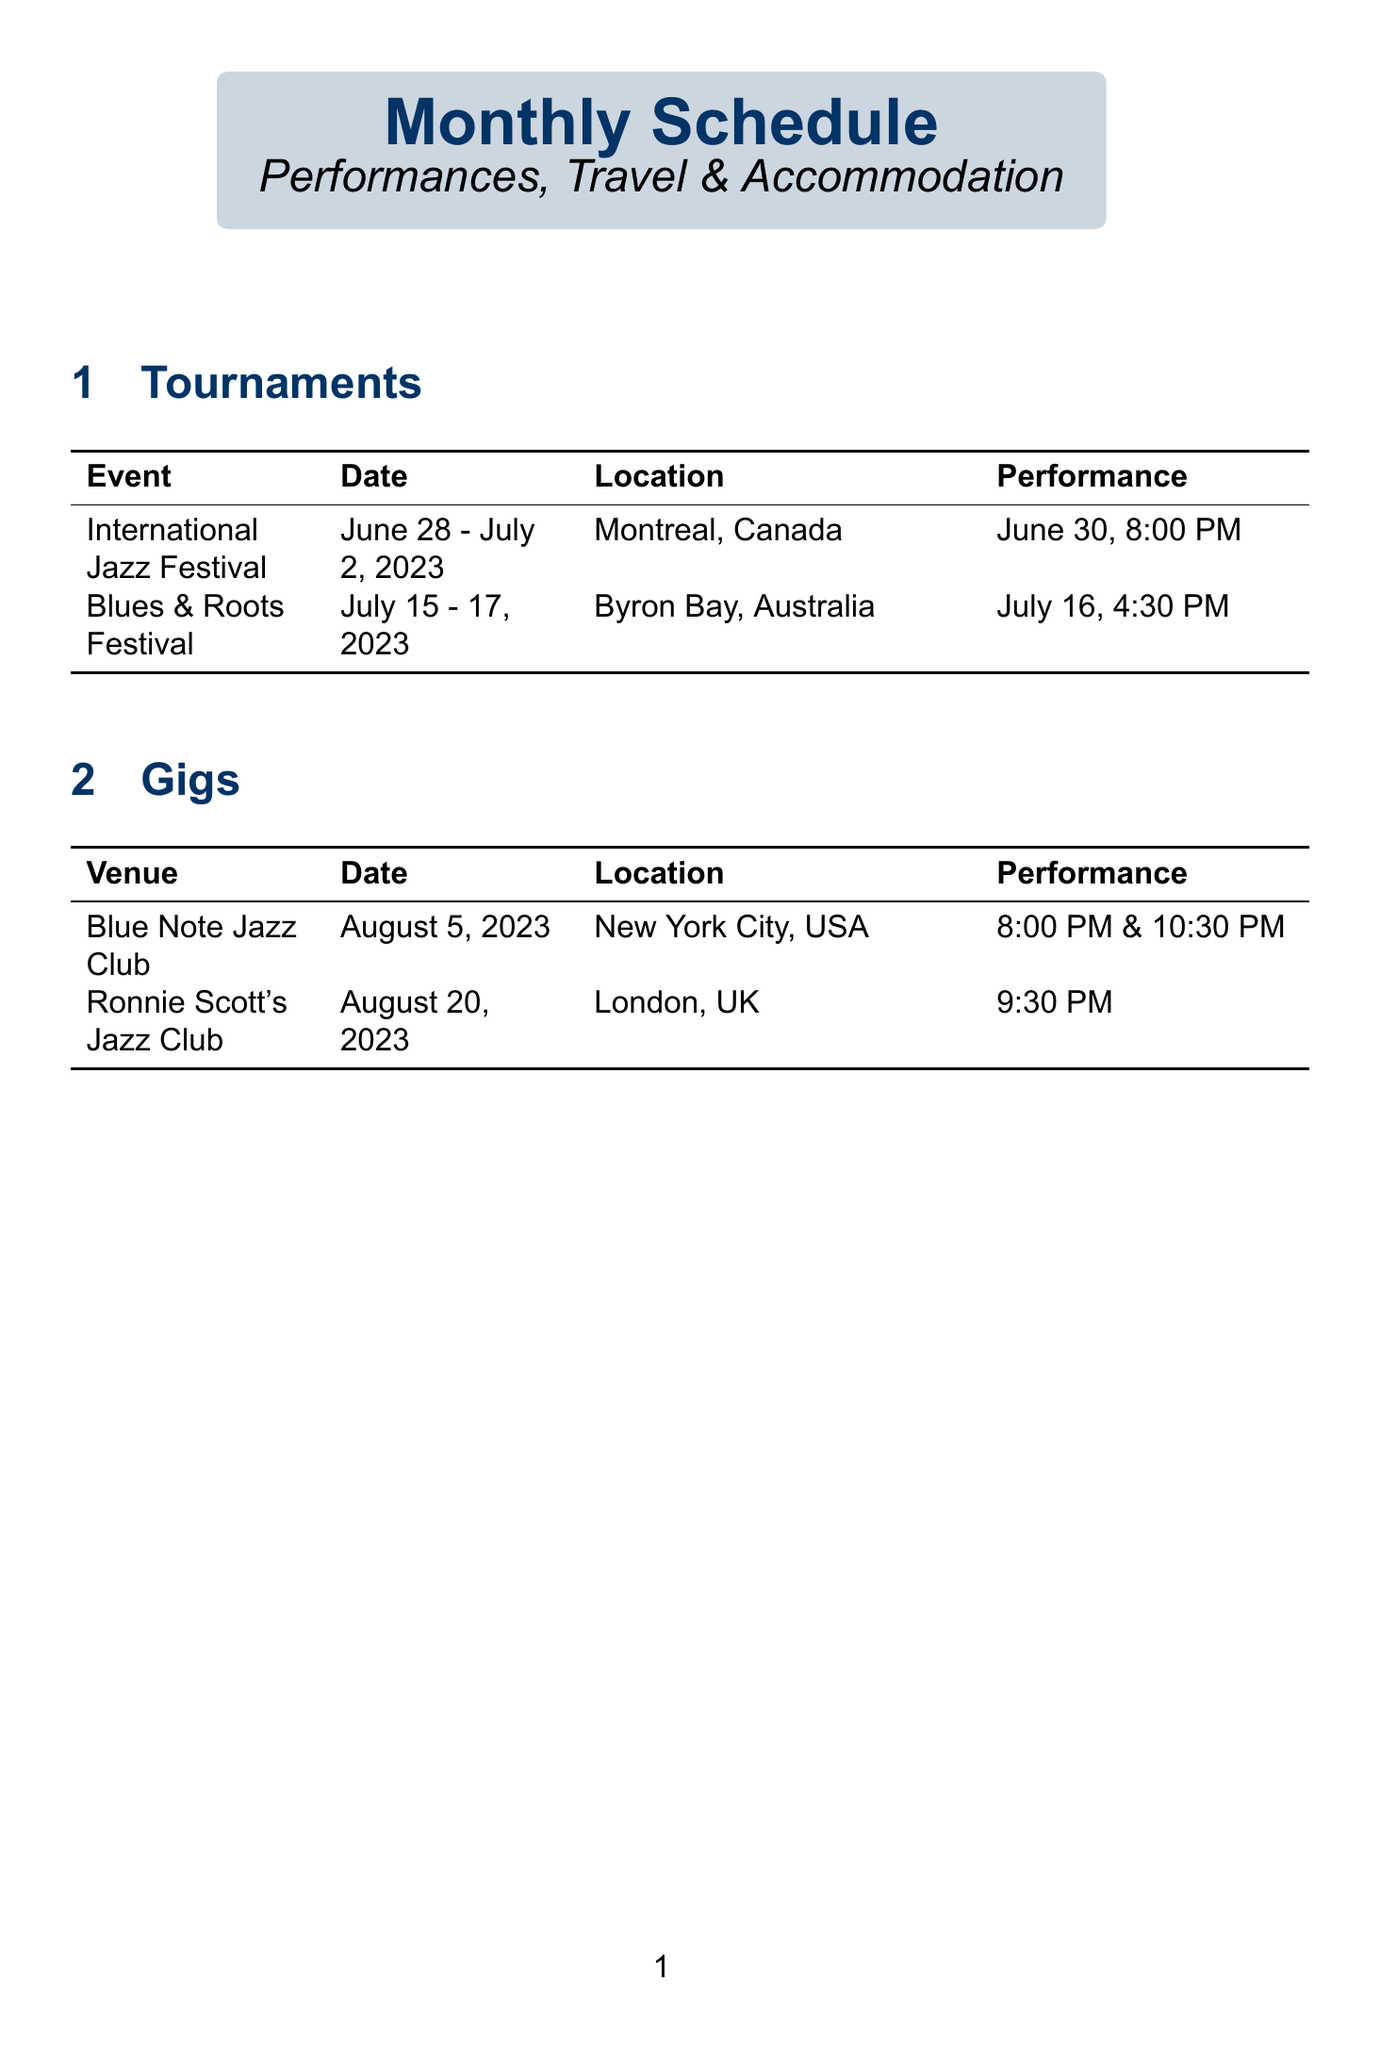What is the performance date for the International Jazz Festival? The performance date for the International Jazz Festival is explicitly stated in the document.
Answer: June 30, 8:00 PM Where is the Blues & Roots Festival located? The document specifies the location of the Blues & Roots Festival in the dedicated tournaments section.
Answer: Byron Bay, Australia What is the check-out date for the accommodation in New York City? The check-out date for the accommodation is given in the travel and accommodation section of the document.
Answer: August 6 What travel transport will be used for the Ronnie Scott's Jazz Club gig? The document outlines the travel arrangements in the gigs section, including the transport for the Ronnie Scott's Jazz Club.
Answer: British Airways flight BA112 How many days will the International Jazz Festival last? The duration of the International Jazz Festival is mentioned in the tournament details.
Answer: 5 days What is one health and wellness tip provided in the document? The document lists health and wellness tips specifically tailored for performers.
Answer: Schedule regular exercise during travel Which performance has two showtimes? The document details the performance times for each gig, highlighting any with multiple showtimes.
Answer: Blue Note Jazz Club When does the travel for the Blues & Roots Festival start? The travel schedule details provide the departure date for the Blues & Roots Festival.
Answer: July 13 